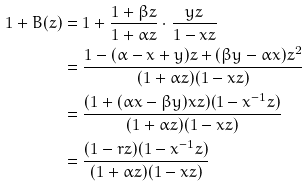<formula> <loc_0><loc_0><loc_500><loc_500>1 + B ( z ) & = 1 + \frac { 1 + \beta z } { 1 + \alpha z } \cdot \frac { y z } { 1 - x z } \\ & = \frac { 1 - ( \alpha - x + y ) z + ( \beta y - \alpha x ) z ^ { 2 } } { ( 1 + \alpha z ) ( 1 - x z ) } \\ & = \frac { ( 1 + ( \alpha x - \beta y ) x z ) ( 1 - x ^ { - 1 } z ) } { ( 1 + \alpha z ) ( 1 - x z ) } \\ & = \frac { ( 1 - r z ) ( 1 - x ^ { - 1 } z ) } { ( 1 + \alpha z ) ( 1 - x z ) }</formula> 